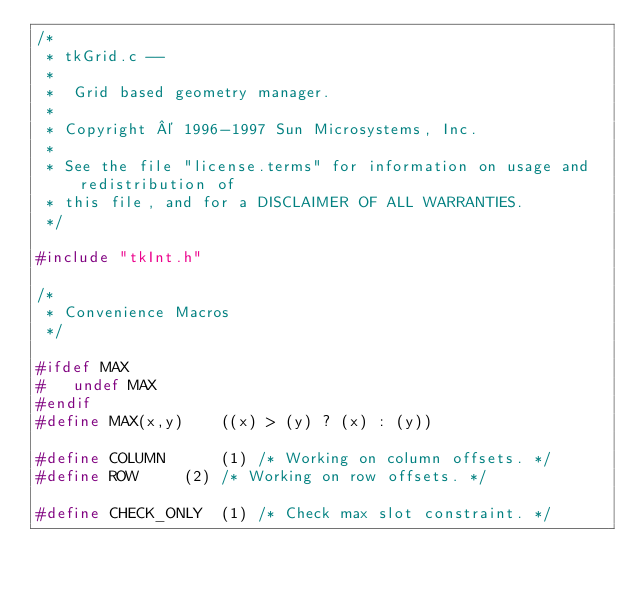Convert code to text. <code><loc_0><loc_0><loc_500><loc_500><_C_>/*
 * tkGrid.c --
 *
 *	Grid based geometry manager.
 *
 * Copyright © 1996-1997 Sun Microsystems, Inc.
 *
 * See the file "license.terms" for information on usage and redistribution of
 * this file, and for a DISCLAIMER OF ALL WARRANTIES.
 */

#include "tkInt.h"

/*
 * Convenience Macros
 */

#ifdef MAX
#   undef MAX
#endif
#define MAX(x,y)	((x) > (y) ? (x) : (y))

#define COLUMN		(1)	/* Working on column offsets. */
#define ROW		(2)	/* Working on row offsets. */

#define CHECK_ONLY	(1)	/* Check max slot constraint. */</code> 